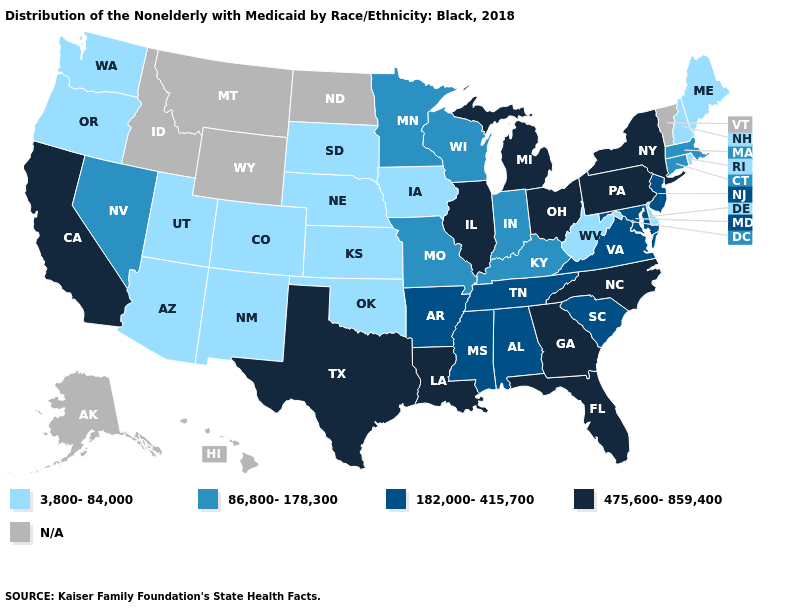What is the value of New Jersey?
Write a very short answer. 182,000-415,700. Name the states that have a value in the range 475,600-859,400?
Concise answer only. California, Florida, Georgia, Illinois, Louisiana, Michigan, New York, North Carolina, Ohio, Pennsylvania, Texas. Name the states that have a value in the range 182,000-415,700?
Keep it brief. Alabama, Arkansas, Maryland, Mississippi, New Jersey, South Carolina, Tennessee, Virginia. What is the highest value in states that border West Virginia?
Keep it brief. 475,600-859,400. Does South Carolina have the highest value in the USA?
Concise answer only. No. How many symbols are there in the legend?
Write a very short answer. 5. What is the lowest value in states that border Florida?
Give a very brief answer. 182,000-415,700. Name the states that have a value in the range 475,600-859,400?
Quick response, please. California, Florida, Georgia, Illinois, Louisiana, Michigan, New York, North Carolina, Ohio, Pennsylvania, Texas. What is the highest value in states that border California?
Be succinct. 86,800-178,300. Does the first symbol in the legend represent the smallest category?
Keep it brief. Yes. Does Indiana have the highest value in the MidWest?
Short answer required. No. Among the states that border Kansas , which have the lowest value?
Keep it brief. Colorado, Nebraska, Oklahoma. What is the value of Virginia?
Concise answer only. 182,000-415,700. Which states have the lowest value in the USA?
Keep it brief. Arizona, Colorado, Delaware, Iowa, Kansas, Maine, Nebraska, New Hampshire, New Mexico, Oklahoma, Oregon, Rhode Island, South Dakota, Utah, Washington, West Virginia. 